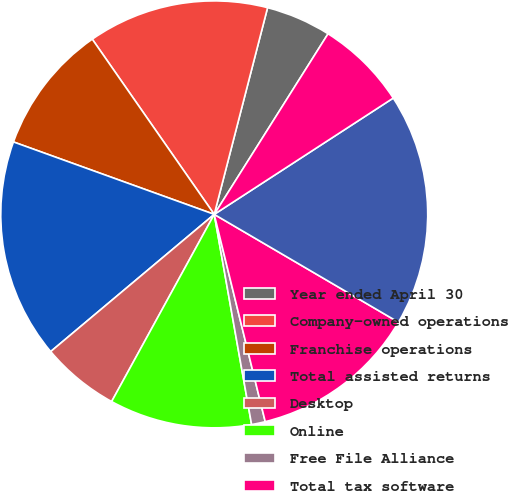<chart> <loc_0><loc_0><loc_500><loc_500><pie_chart><fcel>Year ended April 30<fcel>Company-owned operations<fcel>Franchise operations<fcel>Total assisted returns<fcel>Desktop<fcel>Online<fcel>Free File Alliance<fcel>Total tax software<fcel>Total US returns<fcel>Canada (1)<nl><fcel>4.93%<fcel>13.7%<fcel>9.81%<fcel>16.62%<fcel>5.91%<fcel>10.78%<fcel>1.04%<fcel>12.73%<fcel>17.6%<fcel>6.88%<nl></chart> 